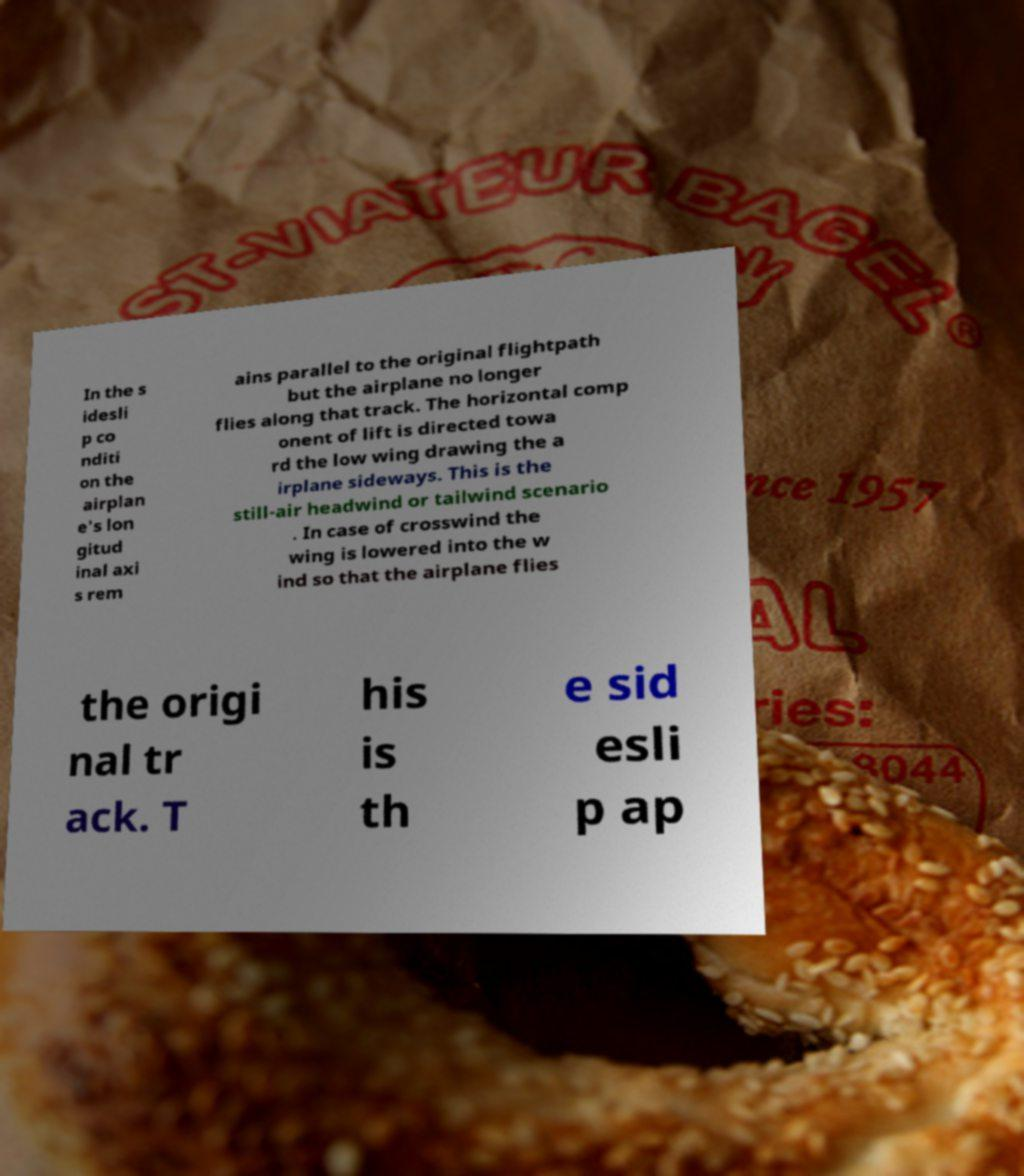Please read and relay the text visible in this image. What does it say? In the s idesli p co nditi on the airplan e's lon gitud inal axi s rem ains parallel to the original flightpath but the airplane no longer flies along that track. The horizontal comp onent of lift is directed towa rd the low wing drawing the a irplane sideways. This is the still-air headwind or tailwind scenario . In case of crosswind the wing is lowered into the w ind so that the airplane flies the origi nal tr ack. T his is th e sid esli p ap 